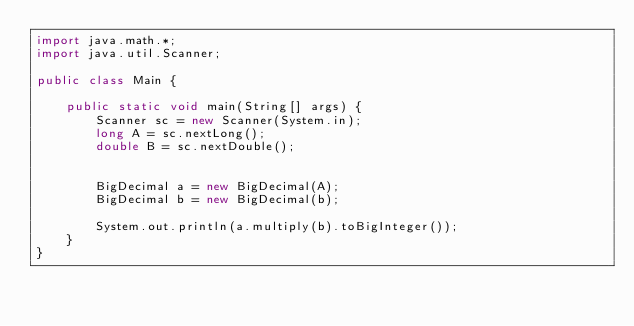<code> <loc_0><loc_0><loc_500><loc_500><_Java_>import java.math.*;
import java.util.Scanner;

public class Main {

    public static void main(String[] args) {
        Scanner sc = new Scanner(System.in);
        long A = sc.nextLong();
        double B = sc.nextDouble();


        BigDecimal a = new BigDecimal(A);
        BigDecimal b = new BigDecimal(b);

        System.out.println(a.multiply(b).toBigInteger());
    }
}</code> 